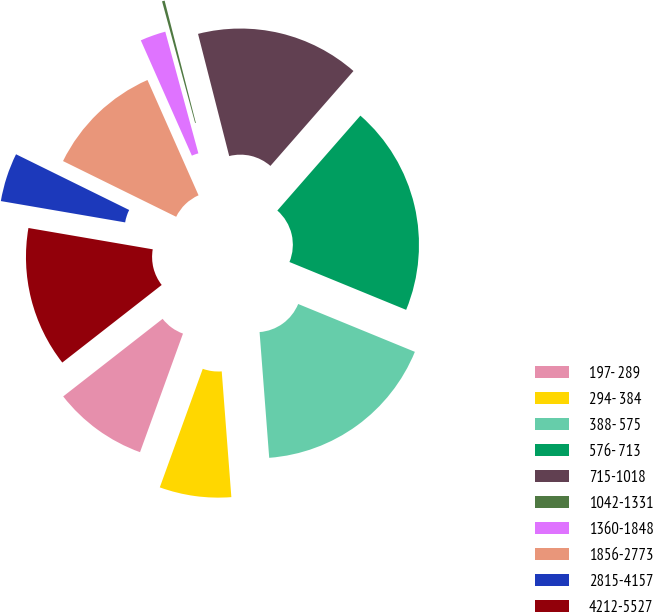Convert chart. <chart><loc_0><loc_0><loc_500><loc_500><pie_chart><fcel>197- 289<fcel>294- 384<fcel>388- 575<fcel>576- 713<fcel>715-1018<fcel>1042-1331<fcel>1360-1848<fcel>1856-2773<fcel>2815-4157<fcel>4212-5527<nl><fcel>8.92%<fcel>6.75%<fcel>17.59%<fcel>19.75%<fcel>15.42%<fcel>0.25%<fcel>2.41%<fcel>11.08%<fcel>4.58%<fcel>13.25%<nl></chart> 